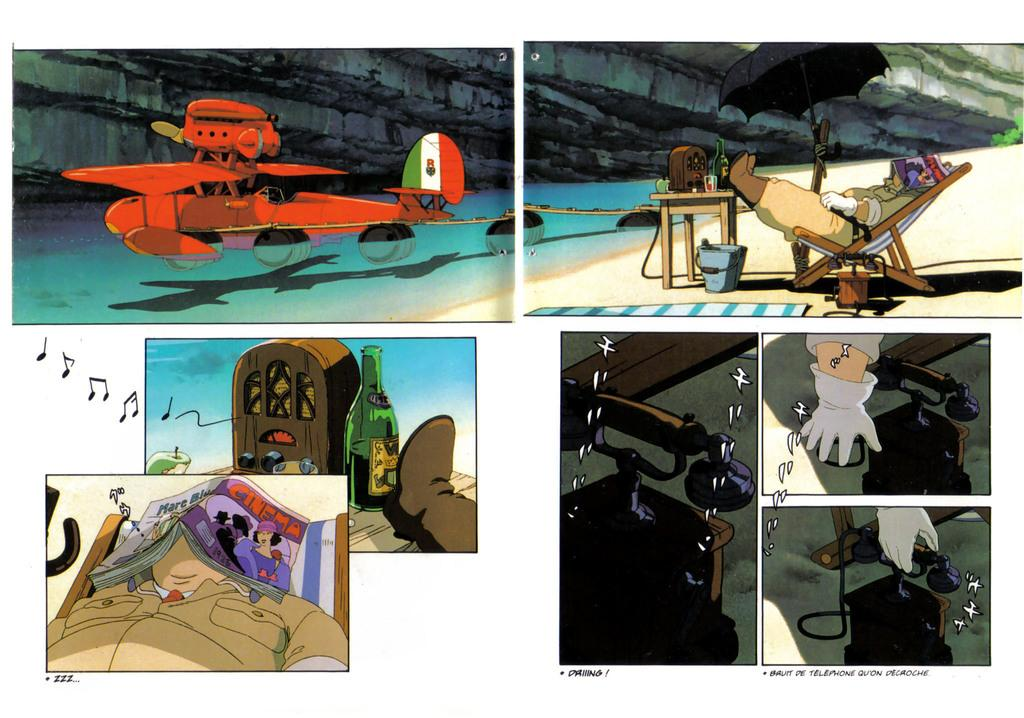Provide a one-sentence caption for the provided image. a cartoon with several panes, one of which has a man sleeping nder a magazine with a cinema ad on the back. 